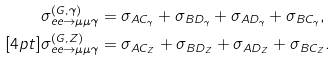<formula> <loc_0><loc_0><loc_500><loc_500>\sigma ^ { ( G , \gamma ) } _ { e e \to \mu \mu \gamma } & = \sigma _ { A C _ { \gamma } } + \sigma _ { B D _ { \gamma } } + \sigma _ { A D _ { \gamma } } + \sigma _ { B C _ { \gamma } } , \\ [ 4 p t ] \sigma ^ { ( G , Z ) } _ { e e \to \mu \mu \gamma } & = \sigma _ { A C _ { Z } } + \sigma _ { B D _ { Z } } + \sigma _ { A D _ { Z } } + \sigma _ { B C _ { Z } } .</formula> 